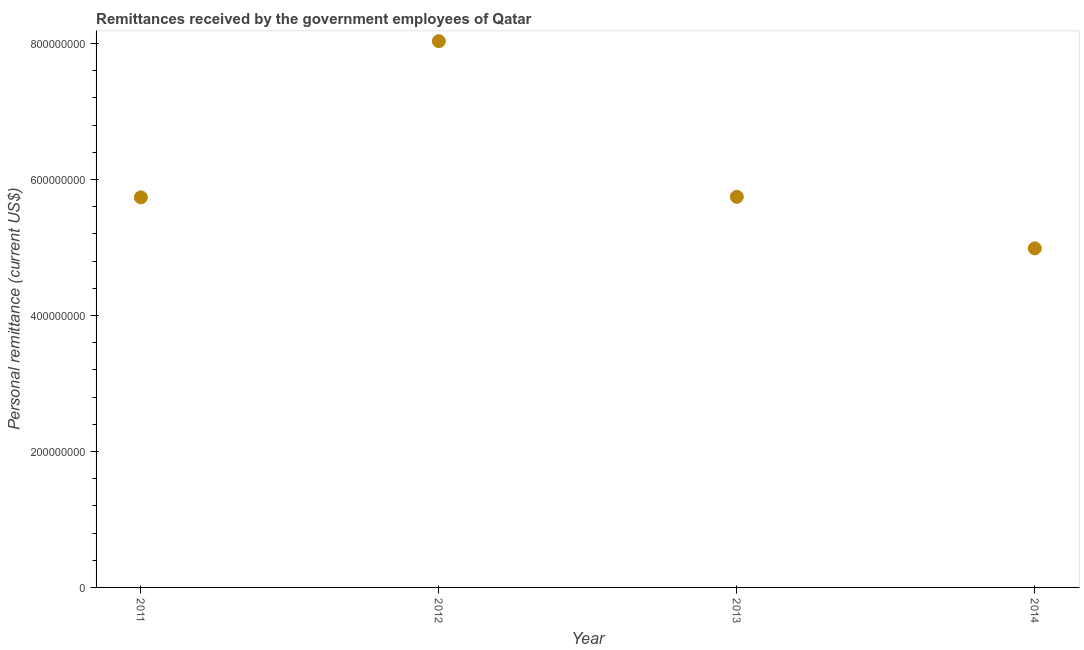What is the personal remittances in 2014?
Provide a succinct answer. 4.99e+08. Across all years, what is the maximum personal remittances?
Offer a terse response. 8.03e+08. Across all years, what is the minimum personal remittances?
Your answer should be compact. 4.99e+08. In which year was the personal remittances maximum?
Provide a succinct answer. 2012. What is the sum of the personal remittances?
Provide a succinct answer. 2.45e+09. What is the difference between the personal remittances in 2011 and 2013?
Your answer should be compact. -7.69e+05. What is the average personal remittances per year?
Offer a terse response. 6.12e+08. What is the median personal remittances?
Your answer should be compact. 5.74e+08. What is the ratio of the personal remittances in 2011 to that in 2012?
Provide a succinct answer. 0.71. Is the personal remittances in 2011 less than that in 2013?
Make the answer very short. Yes. What is the difference between the highest and the second highest personal remittances?
Offer a very short reply. 2.29e+08. Is the sum of the personal remittances in 2011 and 2014 greater than the maximum personal remittances across all years?
Provide a short and direct response. Yes. What is the difference between the highest and the lowest personal remittances?
Make the answer very short. 3.05e+08. How many dotlines are there?
Ensure brevity in your answer.  1. How many years are there in the graph?
Offer a terse response. 4. Are the values on the major ticks of Y-axis written in scientific E-notation?
Offer a very short reply. No. Does the graph contain any zero values?
Your response must be concise. No. What is the title of the graph?
Provide a short and direct response. Remittances received by the government employees of Qatar. What is the label or title of the Y-axis?
Make the answer very short. Personal remittance (current US$). What is the Personal remittance (current US$) in 2011?
Offer a terse response. 5.74e+08. What is the Personal remittance (current US$) in 2012?
Keep it short and to the point. 8.03e+08. What is the Personal remittance (current US$) in 2013?
Provide a succinct answer. 5.74e+08. What is the Personal remittance (current US$) in 2014?
Offer a very short reply. 4.99e+08. What is the difference between the Personal remittance (current US$) in 2011 and 2012?
Provide a short and direct response. -2.30e+08. What is the difference between the Personal remittance (current US$) in 2011 and 2013?
Your response must be concise. -7.69e+05. What is the difference between the Personal remittance (current US$) in 2011 and 2014?
Make the answer very short. 7.50e+07. What is the difference between the Personal remittance (current US$) in 2012 and 2013?
Make the answer very short. 2.29e+08. What is the difference between the Personal remittance (current US$) in 2012 and 2014?
Your answer should be very brief. 3.05e+08. What is the difference between the Personal remittance (current US$) in 2013 and 2014?
Your answer should be very brief. 7.58e+07. What is the ratio of the Personal remittance (current US$) in 2011 to that in 2012?
Your answer should be very brief. 0.71. What is the ratio of the Personal remittance (current US$) in 2011 to that in 2014?
Your response must be concise. 1.15. What is the ratio of the Personal remittance (current US$) in 2012 to that in 2013?
Make the answer very short. 1.4. What is the ratio of the Personal remittance (current US$) in 2012 to that in 2014?
Give a very brief answer. 1.61. What is the ratio of the Personal remittance (current US$) in 2013 to that in 2014?
Provide a succinct answer. 1.15. 